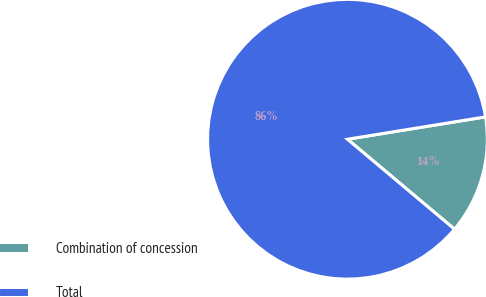Convert chart. <chart><loc_0><loc_0><loc_500><loc_500><pie_chart><fcel>Combination of concession<fcel>Total<nl><fcel>13.68%<fcel>86.32%<nl></chart> 